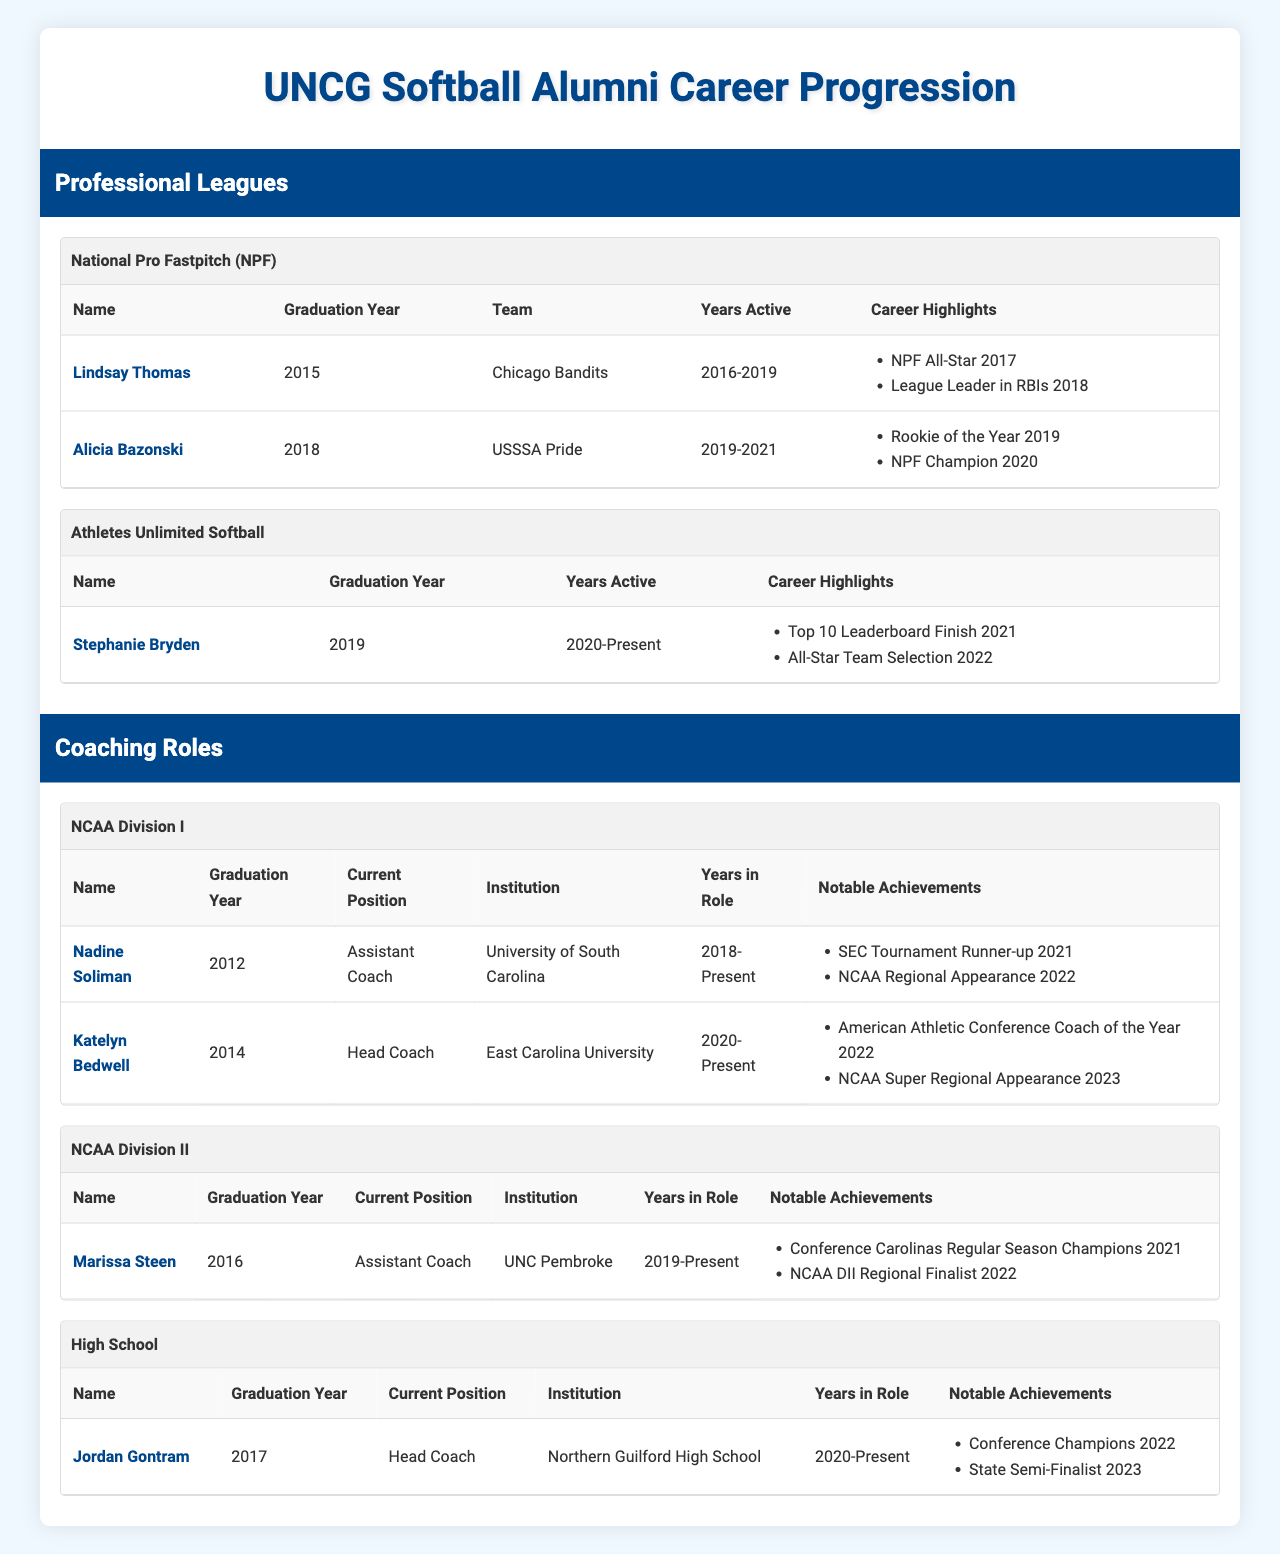What is the name of the UNCG softball alumna who was an NPF All-Star in 2017? Referring to the NPF section of the table, the alumna who was recognized as an NPF All-Star in 2017 is Lindsay Thomas.
Answer: Lindsay Thomas How many years was Alicia Bazonski active in professional leagues? By checking the "Years Active" for Alicia Bazonski, which states "2019-2021," we can calculate that she was active for 3 years (2019, 2020, 2021).
Answer: 3 years Which institution does Katelyn Bedwell currently coach for, and what is her role? From the NCAA Division I coaching roles, Katelyn Bedwell is the Head Coach at East Carolina University.
Answer: East Carolina University, Head Coach Did Stephanie Bryden graduate before or after 2018? By checking the graduation year for Stephanie Bryden, which is 2019, we see she graduated after 2018.
Answer: After 2018 Which coaching role achieved a notable achievement of "NCAA Super Regional Appearance 2023"? Looking at the coaching roles in NCAA Division I, Katelyn Bedwell is noted for the achievement "NCAA Super Regional Appearance 2023."
Answer: Katelyn Bedwell How many total individuals from UNCG are listed as coaching in high school? In the "High School" coaching section, there is one individual listed: Jordan Gontram. Thus, the total is 1.
Answer: 1 What is the difference between the graduation years of the oldest and youngest alumni active in professional leagues? The oldest alumna in the professional leagues is Lindsay Thomas, graduating in 2015, and the youngest is Alicia Bazonski, graduating in 2018. The difference between their graduation years is 2018 - 2015 = 3 years.
Answer: 3 years Is Nadine Soliman involved in coaching at the NCAA Division I level, and what is her current role? Yes, Nadine Soliman is involved in coaching at the NCAA Division I level as an Assistant Coach at the University of South Carolina.
Answer: Yes, Assistant Coach Which player had the career highlight of "League Leader in RBIs 2018"? The player with the career highlight of "League Leader in RBIs 2018" is Lindsay Thomas, as noted in the NPF section.
Answer: Lindsay Thomas List the names of UNCG alumni who have coaching roles in NCAA Division II. In the NCAA Division II section, Marissa Steen is the only alumna listed as an Assistant Coach at UNC Pembroke.
Answer: Marissa Steen 